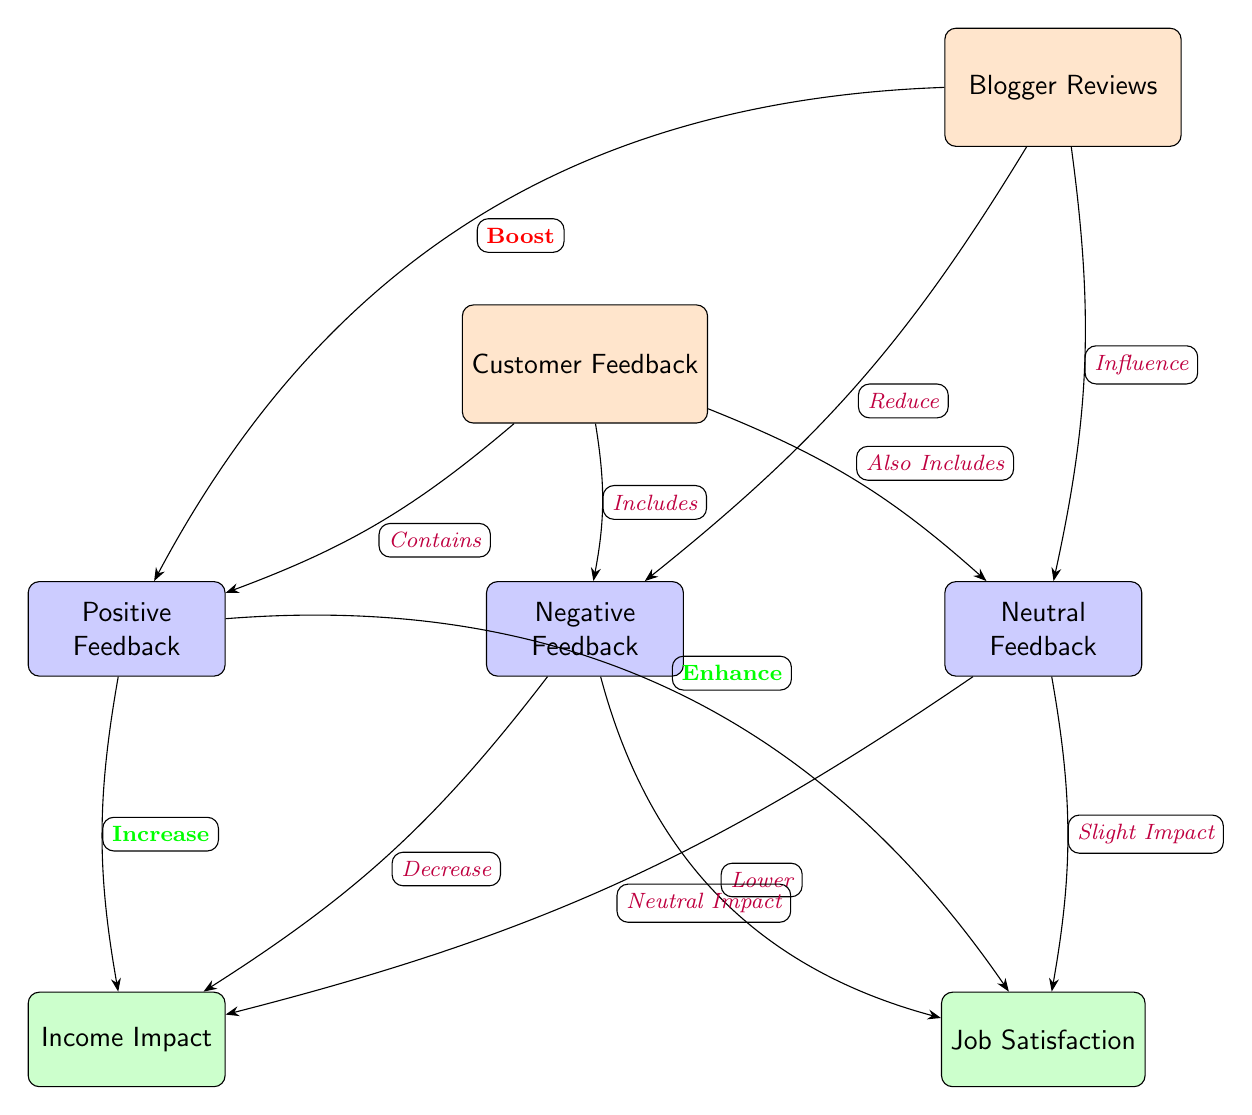What types of customer feedback are represented in the diagram? The diagram shows three types of feedback: Positive, Negative, and Neutral. These are located below the main node labeled "Customer Feedback."
Answer: Positive, Negative, Neutral What impact does positive feedback have on income? According to the diagram, positive feedback has a direct relationship that indicates it will "Increase" income, which is represented by an edge connecting these two nodes.
Answer: Increase How many main nodes are present in this diagram? The main nodes identified in the diagram are "Customer Feedback" and "Blogger Reviews," resulting in a total of two main nodes.
Answer: 2 What does the diagram illustrate about the relationship between blogger reviews and negative feedback? The edge connecting "Blogger Reviews" and "Negative Feedback" indicates that blogger reviews "Reduce" negative feedback. This establishes a causal relationship in the reverse direction.
Answer: Reduce If positive feedback enhances job satisfaction, what is the corresponding relationship for negative feedback? The diagram indicates that negative feedback has a relationship "Lower" job satisfaction. This infers a negative impact of negative feedback compared to the positive effects of positive feedback on job satisfaction.
Answer: Lower What is the connection between neutral feedback and income impact? The diagram states that neutral feedback has a "Neutral Impact" on income, indicating it does not favorably or unfavorably affect income when considering customer sentiment.
Answer: Neutral Impact What is the influence of blogger reviews on neutral feedback according to the diagram? The diagram shows that blogger reviews "Influence" neutral feedback, suggesting they can sway how customers feel neutrally regarding their experiences.
Answer: Influence How many edges connect customer feedback to the various types of feedback? There are three edges connecting "Customer Feedback" to the different types of feedback: one for each type (Positive, Negative, Neutral).
Answer: 3 What sentiment does positive feedback correlate with when considering blogger reviews? According to the diagram, positive feedback correlates with an increase in both income and job satisfaction when influenced by blogger reviews.
Answer: Increase (income), Enhance (job satisfaction) 